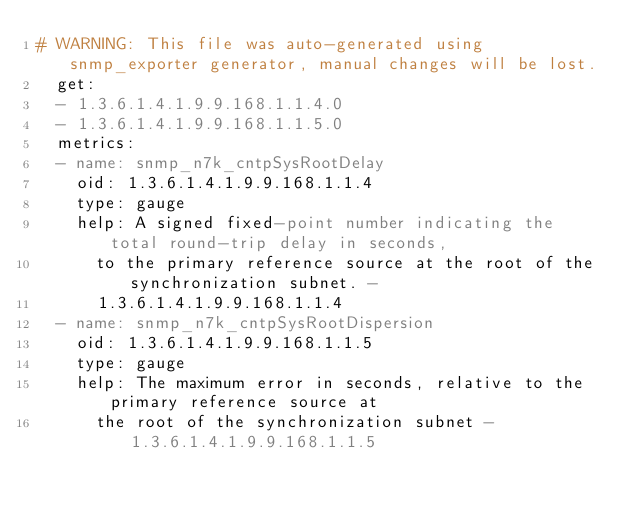<code> <loc_0><loc_0><loc_500><loc_500><_YAML_># WARNING: This file was auto-generated using snmp_exporter generator, manual changes will be lost.
  get:
  - 1.3.6.1.4.1.9.9.168.1.1.4.0
  - 1.3.6.1.4.1.9.9.168.1.1.5.0
  metrics:
  - name: snmp_n7k_cntpSysRootDelay
    oid: 1.3.6.1.4.1.9.9.168.1.1.4
    type: gauge
    help: A signed fixed-point number indicating the total round-trip delay in seconds,
      to the primary reference source at the root of the synchronization subnet. -
      1.3.6.1.4.1.9.9.168.1.1.4
  - name: snmp_n7k_cntpSysRootDispersion
    oid: 1.3.6.1.4.1.9.9.168.1.1.5
    type: gauge
    help: The maximum error in seconds, relative to the primary reference source at
      the root of the synchronization subnet - 1.3.6.1.4.1.9.9.168.1.1.5
</code> 